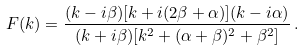<formula> <loc_0><loc_0><loc_500><loc_500>F ( k ) = \frac { ( k - i \beta ) [ k + i ( 2 \beta + \alpha ) ] ( k - i \alpha ) } { ( k + i \beta ) [ k ^ { 2 } + ( \alpha + \beta ) ^ { 2 } + \beta ^ { 2 } ] } \, .</formula> 